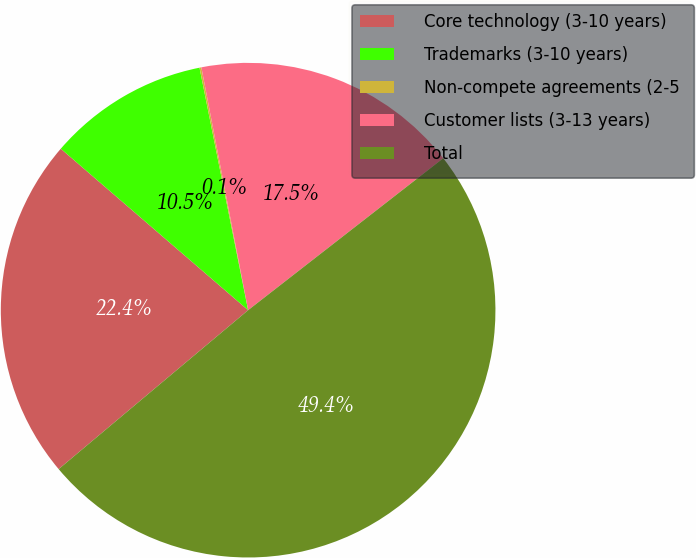Convert chart to OTSL. <chart><loc_0><loc_0><loc_500><loc_500><pie_chart><fcel>Core technology (3-10 years)<fcel>Trademarks (3-10 years)<fcel>Non-compete agreements (2-5<fcel>Customer lists (3-13 years)<fcel>Total<nl><fcel>22.43%<fcel>10.53%<fcel>0.12%<fcel>17.5%<fcel>49.42%<nl></chart> 